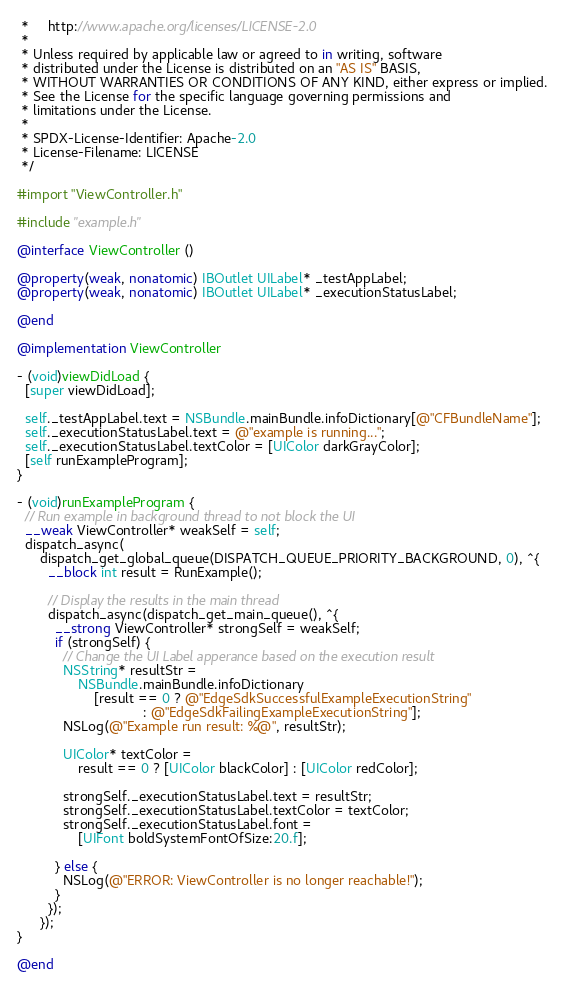Convert code to text. <code><loc_0><loc_0><loc_500><loc_500><_ObjectiveC_> *     http://www.apache.org/licenses/LICENSE-2.0
 *
 * Unless required by applicable law or agreed to in writing, software
 * distributed under the License is distributed on an "AS IS" BASIS,
 * WITHOUT WARRANTIES OR CONDITIONS OF ANY KIND, either express or implied.
 * See the License for the specific language governing permissions and
 * limitations under the License.
 *
 * SPDX-License-Identifier: Apache-2.0
 * License-Filename: LICENSE
 */

#import "ViewController.h"

#include "example.h"

@interface ViewController ()

@property(weak, nonatomic) IBOutlet UILabel* _testAppLabel;
@property(weak, nonatomic) IBOutlet UILabel* _executionStatusLabel;

@end

@implementation ViewController

- (void)viewDidLoad {
  [super viewDidLoad];

  self._testAppLabel.text = NSBundle.mainBundle.infoDictionary[@"CFBundleName"];
  self._executionStatusLabel.text = @"example is running...";
  self._executionStatusLabel.textColor = [UIColor darkGrayColor];
  [self runExampleProgram];
}

- (void)runExampleProgram {
  // Run example in background thread to not block the UI
  __weak ViewController* weakSelf = self;
  dispatch_async(
      dispatch_get_global_queue(DISPATCH_QUEUE_PRIORITY_BACKGROUND, 0), ^{
        __block int result = RunExample();

        // Display the results in the main thread
        dispatch_async(dispatch_get_main_queue(), ^{
          __strong ViewController* strongSelf = weakSelf;
          if (strongSelf) {
            // Change the UI Label apperance based on the execution result
            NSString* resultStr =
                NSBundle.mainBundle.infoDictionary
                    [result == 0 ? @"EdgeSdkSuccessfulExampleExecutionString"
                                 : @"EdgeSdkFailingExampleExecutionString"];
            NSLog(@"Example run result: %@", resultStr);

            UIColor* textColor =
                result == 0 ? [UIColor blackColor] : [UIColor redColor];

            strongSelf._executionStatusLabel.text = resultStr;
            strongSelf._executionStatusLabel.textColor = textColor;
            strongSelf._executionStatusLabel.font =
                [UIFont boldSystemFontOfSize:20.f];

          } else {
            NSLog(@"ERROR: ViewController is no longer reachable!");
          }
        });
      });
}

@end
</code> 